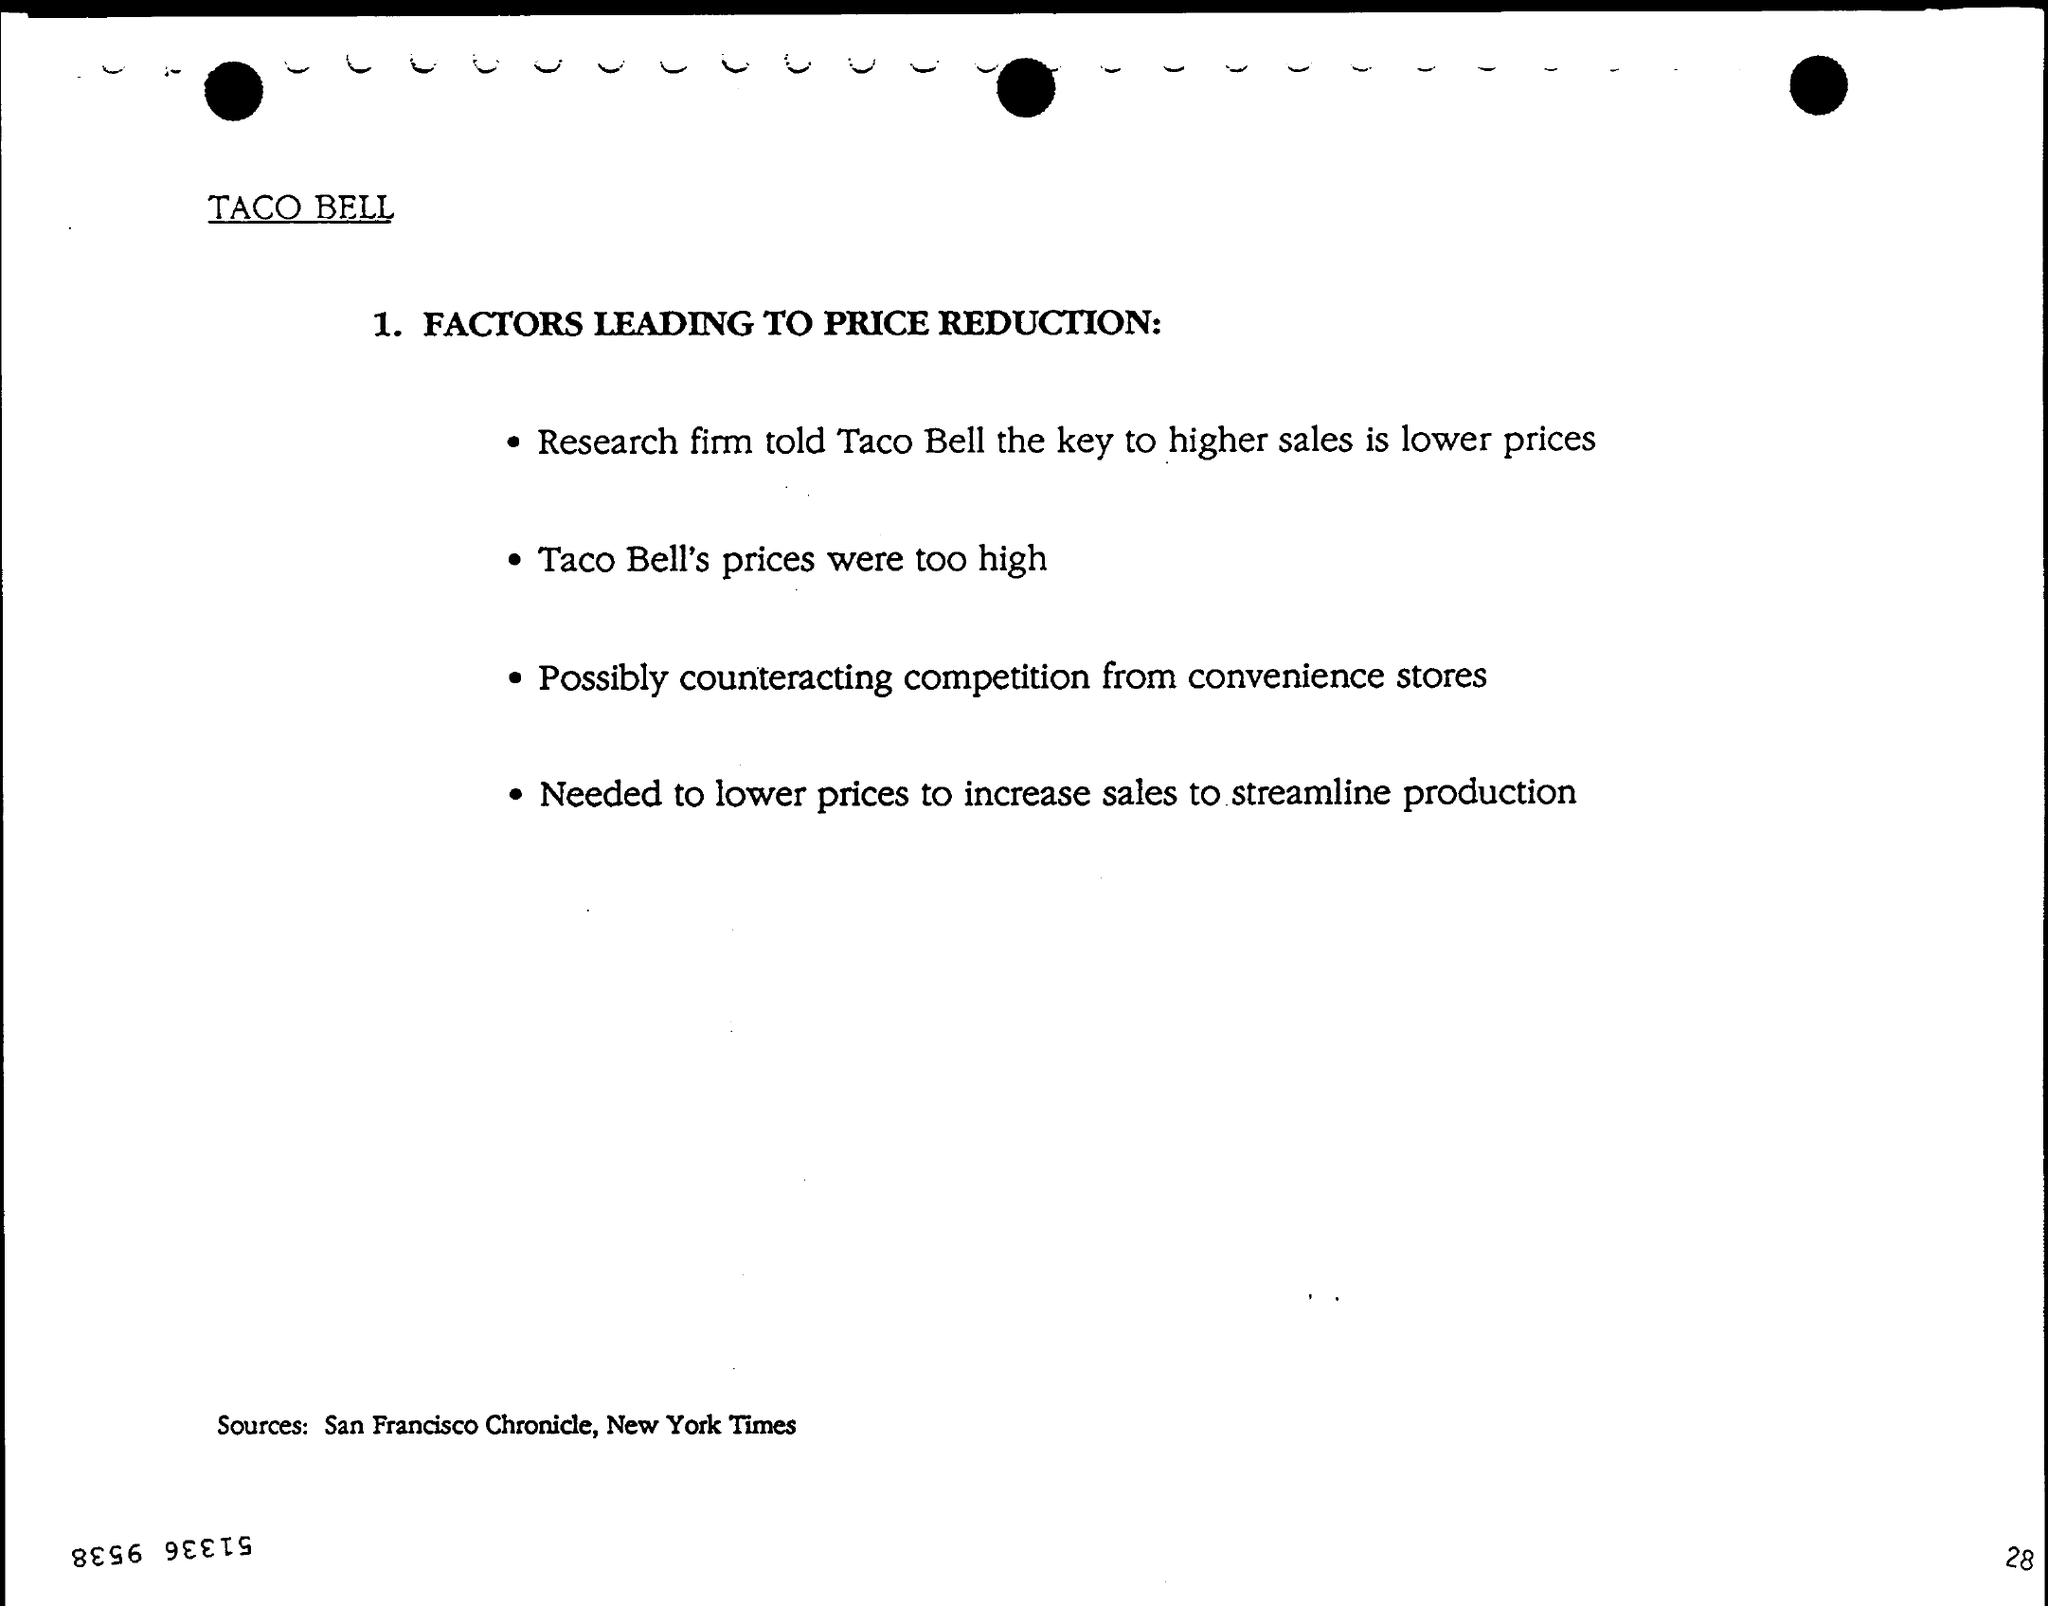Highlight a few significant elements in this photo. The sources for the information are the San Francisco Chronicle and the New York Times. According to a leading research firm, the key to higher sales is actually lower prices. 